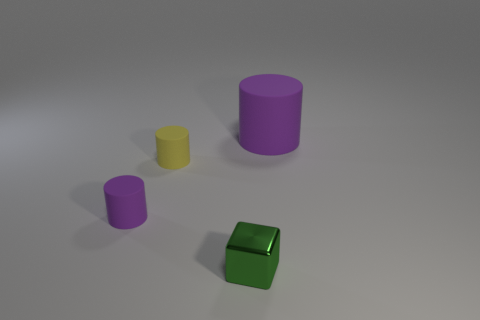Imagine if these objects were part of a toy set, what kind of game could they be used for? Given their simple shapes and distinct colors, these objects could be part of an educational toy set designed for young children. They could be used to teach color recognition, basic counting, and spatial relationships. For example, a game could involve stacking the cylinders or fitting them inside one another based on size, or using the cube to explore concepts of symmetry and balance. 